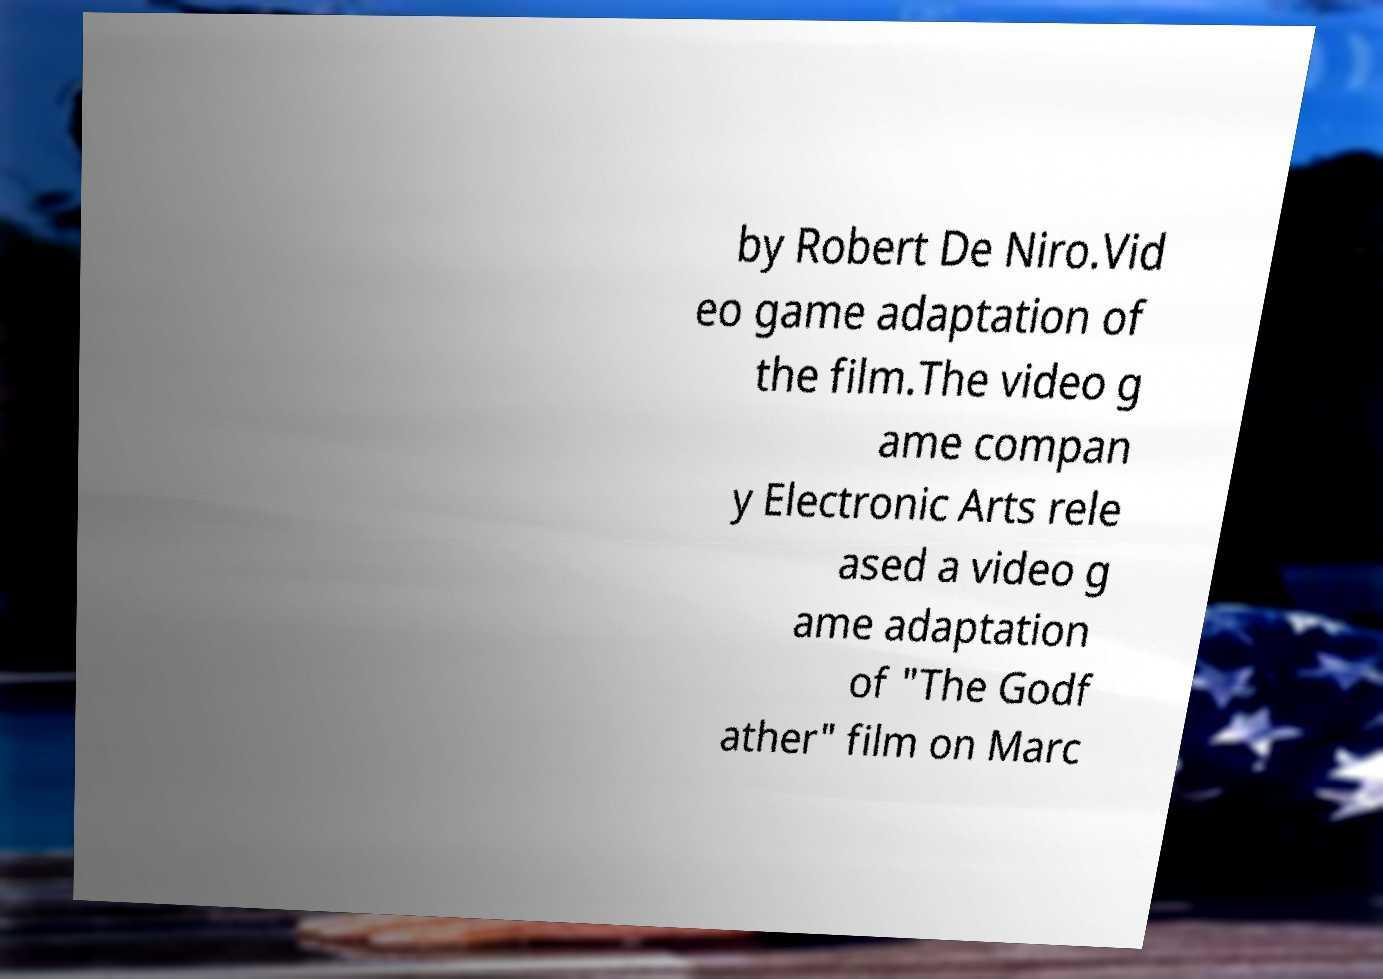Could you extract and type out the text from this image? by Robert De Niro.Vid eo game adaptation of the film.The video g ame compan y Electronic Arts rele ased a video g ame adaptation of "The Godf ather" film on Marc 